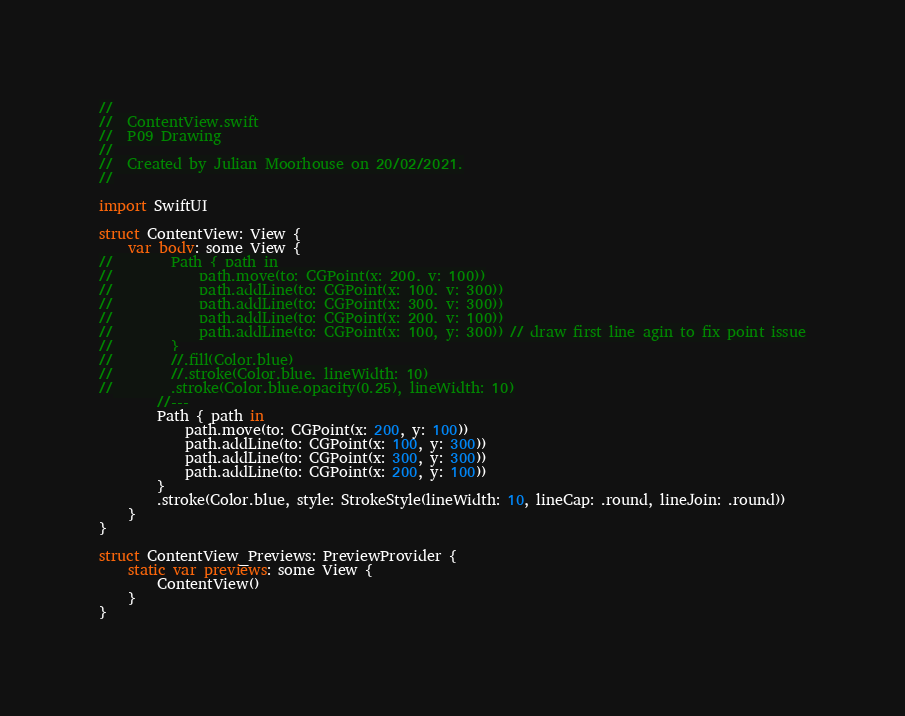<code> <loc_0><loc_0><loc_500><loc_500><_Swift_>//
//  ContentView.swift
//  P09 Drawing
//
//  Created by Julian Moorhouse on 20/02/2021.
//

import SwiftUI

struct ContentView: View {
    var body: some View {
//        Path { path in
//            path.move(to: CGPoint(x: 200, y: 100))
//            path.addLine(to: CGPoint(x: 100, y: 300))
//            path.addLine(to: CGPoint(x: 300, y: 300))
//            path.addLine(to: CGPoint(x: 200, y: 100))
//            path.addLine(to: CGPoint(x: 100, y: 300)) // draw first line agin to fix point issue
//        }
//        //.fill(Color.blue)
//        //.stroke(Color.blue, lineWidth: 10)
//        .stroke(Color.blue.opacity(0.25), lineWidth: 10)
        //---
        Path { path in
            path.move(to: CGPoint(x: 200, y: 100))
            path.addLine(to: CGPoint(x: 100, y: 300))
            path.addLine(to: CGPoint(x: 300, y: 300))
            path.addLine(to: CGPoint(x: 200, y: 100))
        }
        .stroke(Color.blue, style: StrokeStyle(lineWidth: 10, lineCap: .round, lineJoin: .round))
    }
}

struct ContentView_Previews: PreviewProvider {
    static var previews: some View {
        ContentView()
    }
}
</code> 